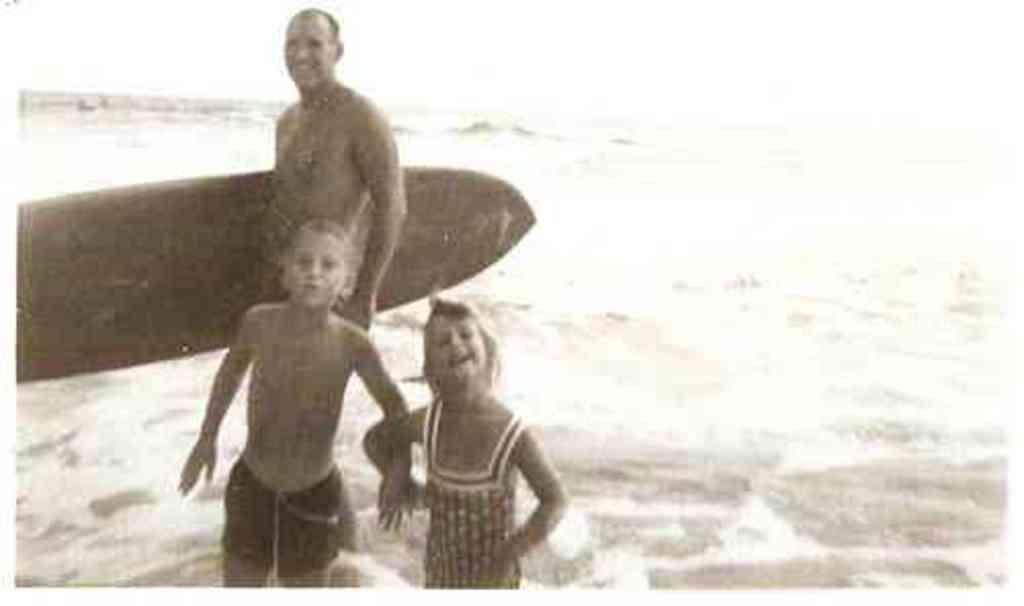In one or two sentences, can you explain what this image depicts? Here this 3 people are standing in water and this man is holding surfboard. 